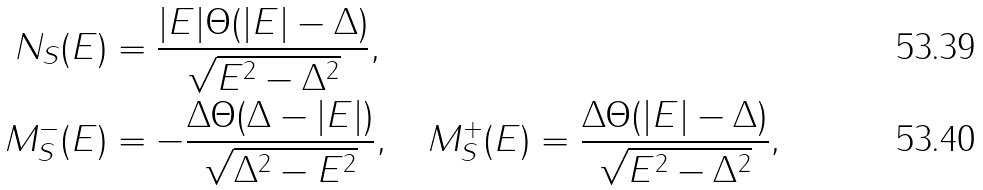<formula> <loc_0><loc_0><loc_500><loc_500>N _ { S } ( E ) & = \frac { | E | \Theta ( | E | - \Delta ) } { \sqrt { E ^ { 2 } - \Delta ^ { 2 } } } , \\ M _ { S } ^ { - } ( E ) & = - \frac { \Delta \Theta ( \Delta - | E | ) } { \sqrt { \Delta ^ { 2 } - E ^ { 2 } } } , \quad M _ { S } ^ { + } ( E ) = \frac { \Delta \Theta ( | E | - \Delta ) } { \sqrt { E ^ { 2 } - \Delta ^ { 2 } } } ,</formula> 